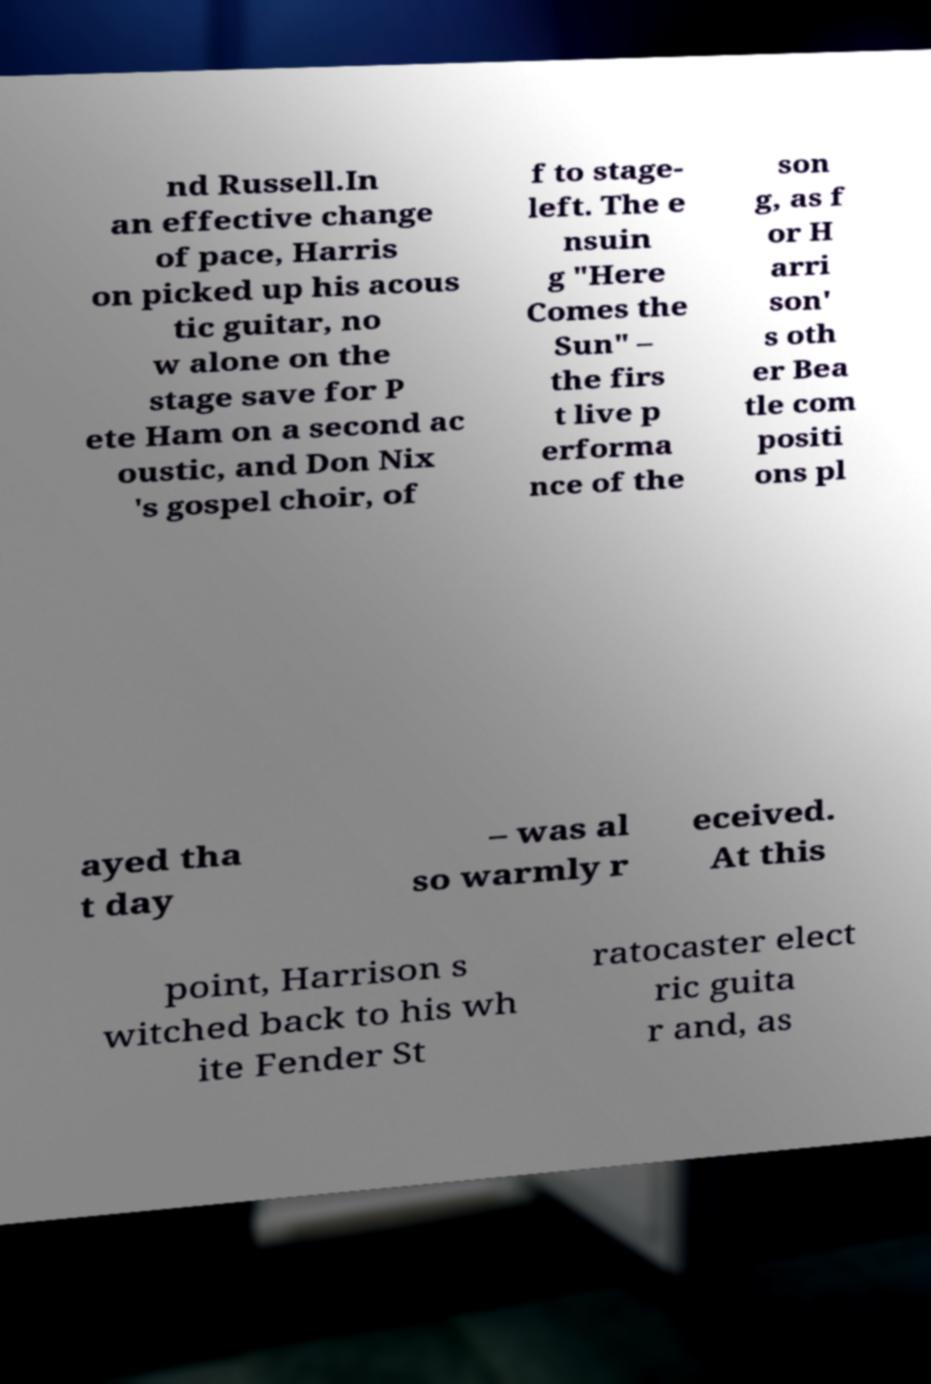I need the written content from this picture converted into text. Can you do that? nd Russell.In an effective change of pace, Harris on picked up his acous tic guitar, no w alone on the stage save for P ete Ham on a second ac oustic, and Don Nix 's gospel choir, of f to stage- left. The e nsuin g "Here Comes the Sun" – the firs t live p erforma nce of the son g, as f or H arri son' s oth er Bea tle com positi ons pl ayed tha t day – was al so warmly r eceived. At this point, Harrison s witched back to his wh ite Fender St ratocaster elect ric guita r and, as 